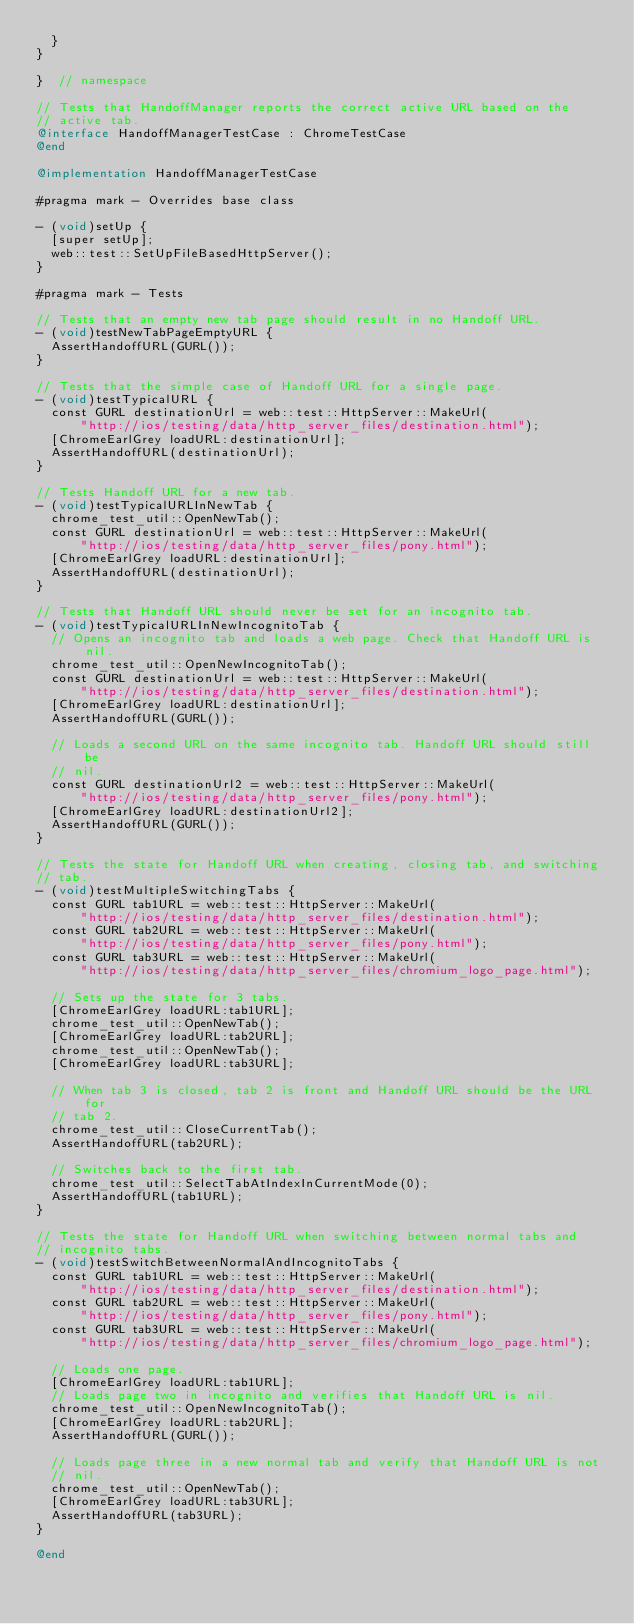<code> <loc_0><loc_0><loc_500><loc_500><_ObjectiveC_>  }
}

}  // namespace

// Tests that HandoffManager reports the correct active URL based on the
// active tab.
@interface HandoffManagerTestCase : ChromeTestCase
@end

@implementation HandoffManagerTestCase

#pragma mark - Overrides base class

- (void)setUp {
  [super setUp];
  web::test::SetUpFileBasedHttpServer();
}

#pragma mark - Tests

// Tests that an empty new tab page should result in no Handoff URL.
- (void)testNewTabPageEmptyURL {
  AssertHandoffURL(GURL());
}

// Tests that the simple case of Handoff URL for a single page.
- (void)testTypicalURL {
  const GURL destinationUrl = web::test::HttpServer::MakeUrl(
      "http://ios/testing/data/http_server_files/destination.html");
  [ChromeEarlGrey loadURL:destinationUrl];
  AssertHandoffURL(destinationUrl);
}

// Tests Handoff URL for a new tab.
- (void)testTypicalURLInNewTab {
  chrome_test_util::OpenNewTab();
  const GURL destinationUrl = web::test::HttpServer::MakeUrl(
      "http://ios/testing/data/http_server_files/pony.html");
  [ChromeEarlGrey loadURL:destinationUrl];
  AssertHandoffURL(destinationUrl);
}

// Tests that Handoff URL should never be set for an incognito tab.
- (void)testTypicalURLInNewIncognitoTab {
  // Opens an incognito tab and loads a web page. Check that Handoff URL is nil.
  chrome_test_util::OpenNewIncognitoTab();
  const GURL destinationUrl = web::test::HttpServer::MakeUrl(
      "http://ios/testing/data/http_server_files/destination.html");
  [ChromeEarlGrey loadURL:destinationUrl];
  AssertHandoffURL(GURL());

  // Loads a second URL on the same incognito tab. Handoff URL should still be
  // nil.
  const GURL destinationUrl2 = web::test::HttpServer::MakeUrl(
      "http://ios/testing/data/http_server_files/pony.html");
  [ChromeEarlGrey loadURL:destinationUrl2];
  AssertHandoffURL(GURL());
}

// Tests the state for Handoff URL when creating, closing tab, and switching
// tab.
- (void)testMultipleSwitchingTabs {
  const GURL tab1URL = web::test::HttpServer::MakeUrl(
      "http://ios/testing/data/http_server_files/destination.html");
  const GURL tab2URL = web::test::HttpServer::MakeUrl(
      "http://ios/testing/data/http_server_files/pony.html");
  const GURL tab3URL = web::test::HttpServer::MakeUrl(
      "http://ios/testing/data/http_server_files/chromium_logo_page.html");

  // Sets up the state for 3 tabs.
  [ChromeEarlGrey loadURL:tab1URL];
  chrome_test_util::OpenNewTab();
  [ChromeEarlGrey loadURL:tab2URL];
  chrome_test_util::OpenNewTab();
  [ChromeEarlGrey loadURL:tab3URL];

  // When tab 3 is closed, tab 2 is front and Handoff URL should be the URL for
  // tab 2.
  chrome_test_util::CloseCurrentTab();
  AssertHandoffURL(tab2URL);

  // Switches back to the first tab.
  chrome_test_util::SelectTabAtIndexInCurrentMode(0);
  AssertHandoffURL(tab1URL);
}

// Tests the state for Handoff URL when switching between normal tabs and
// incognito tabs.
- (void)testSwitchBetweenNormalAndIncognitoTabs {
  const GURL tab1URL = web::test::HttpServer::MakeUrl(
      "http://ios/testing/data/http_server_files/destination.html");
  const GURL tab2URL = web::test::HttpServer::MakeUrl(
      "http://ios/testing/data/http_server_files/pony.html");
  const GURL tab3URL = web::test::HttpServer::MakeUrl(
      "http://ios/testing/data/http_server_files/chromium_logo_page.html");

  // Loads one page.
  [ChromeEarlGrey loadURL:tab1URL];
  // Loads page two in incognito and verifies that Handoff URL is nil.
  chrome_test_util::OpenNewIncognitoTab();
  [ChromeEarlGrey loadURL:tab2URL];
  AssertHandoffURL(GURL());

  // Loads page three in a new normal tab and verify that Handoff URL is not
  // nil.
  chrome_test_util::OpenNewTab();
  [ChromeEarlGrey loadURL:tab3URL];
  AssertHandoffURL(tab3URL);
}

@end
</code> 